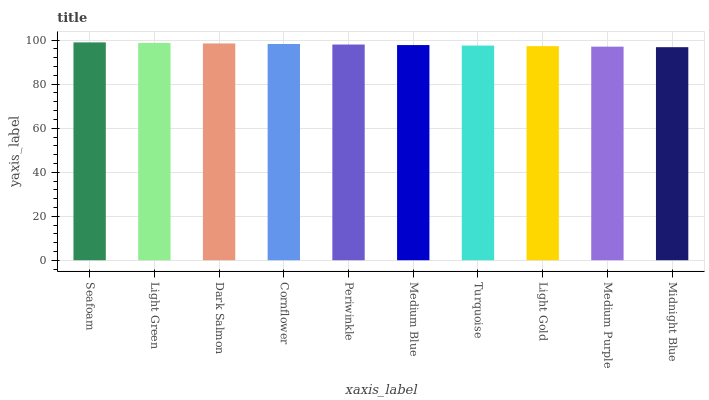Is Midnight Blue the minimum?
Answer yes or no. Yes. Is Seafoam the maximum?
Answer yes or no. Yes. Is Light Green the minimum?
Answer yes or no. No. Is Light Green the maximum?
Answer yes or no. No. Is Seafoam greater than Light Green?
Answer yes or no. Yes. Is Light Green less than Seafoam?
Answer yes or no. Yes. Is Light Green greater than Seafoam?
Answer yes or no. No. Is Seafoam less than Light Green?
Answer yes or no. No. Is Periwinkle the high median?
Answer yes or no. Yes. Is Medium Blue the low median?
Answer yes or no. Yes. Is Midnight Blue the high median?
Answer yes or no. No. Is Turquoise the low median?
Answer yes or no. No. 